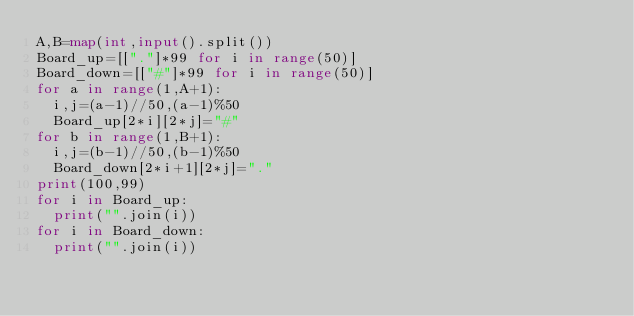Convert code to text. <code><loc_0><loc_0><loc_500><loc_500><_Python_>A,B=map(int,input().split())
Board_up=[["."]*99 for i in range(50)]
Board_down=[["#"]*99 for i in range(50)]
for a in range(1,A+1):
  i,j=(a-1)//50,(a-1)%50
  Board_up[2*i][2*j]="#"
for b in range(1,B+1):
  i,j=(b-1)//50,(b-1)%50
  Board_down[2*i+1][2*j]="."
print(100,99)
for i in Board_up:
  print("".join(i))
for i in Board_down:
  print("".join(i))
  </code> 